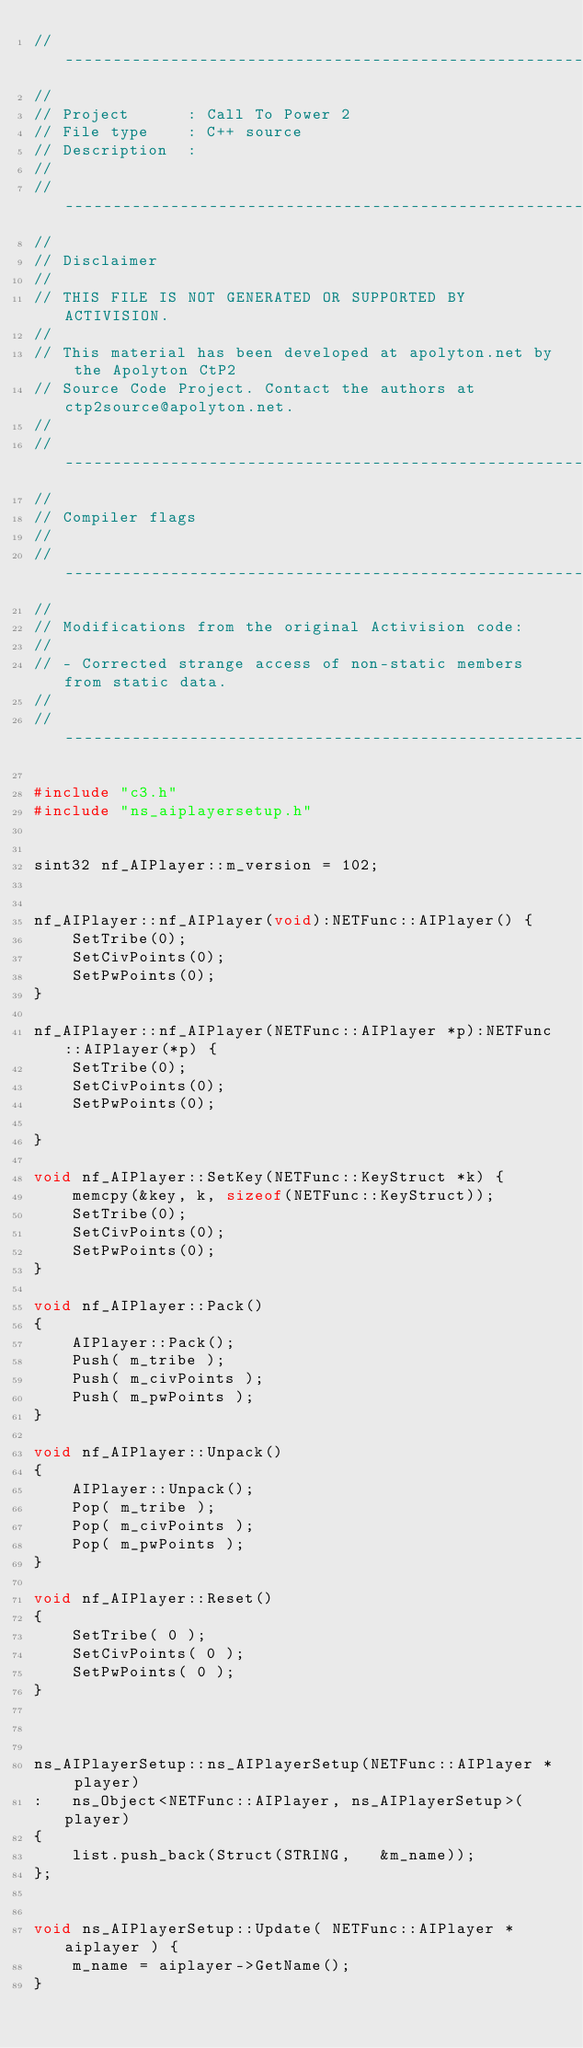Convert code to text. <code><loc_0><loc_0><loc_500><loc_500><_C++_>//----------------------------------------------------------------------------
//
// Project      : Call To Power 2
// File type    : C++ source
// Description  : 
//
//----------------------------------------------------------------------------
//
// Disclaimer
//
// THIS FILE IS NOT GENERATED OR SUPPORTED BY ACTIVISION.
//
// This material has been developed at apolyton.net by the Apolyton CtP2 
// Source Code Project. Contact the authors at ctp2source@apolyton.net.
//
//----------------------------------------------------------------------------
//
// Compiler flags
// 
//----------------------------------------------------------------------------
//
// Modifications from the original Activision code:
//
// - Corrected strange access of non-static members from static data.
//
//----------------------------------------------------------------------------

#include "c3.h"
#include "ns_aiplayersetup.h"


sint32 nf_AIPlayer::m_version = 102;


nf_AIPlayer::nf_AIPlayer(void):NETFunc::AIPlayer() {
	SetTribe(0);
	SetCivPoints(0);
	SetPwPoints(0);
}

nf_AIPlayer::nf_AIPlayer(NETFunc::AIPlayer *p):NETFunc::AIPlayer(*p) {
	SetTribe(0);
	SetCivPoints(0);
	SetPwPoints(0);

}

void nf_AIPlayer::SetKey(NETFunc::KeyStruct *k) {
	memcpy(&key, k, sizeof(NETFunc::KeyStruct));
	SetTribe(0);
	SetCivPoints(0);
	SetPwPoints(0);
}

void nf_AIPlayer::Pack()
{
	AIPlayer::Pack();
	Push( m_tribe );
	Push( m_civPoints );
	Push( m_pwPoints );
}

void nf_AIPlayer::Unpack()
{
	AIPlayer::Unpack();
	Pop( m_tribe );
	Pop( m_civPoints );
	Pop( m_pwPoints );
}

void nf_AIPlayer::Reset()
{
	SetTribe( 0 );
	SetCivPoints( 0 );
	SetPwPoints( 0 );
}



ns_AIPlayerSetup::ns_AIPlayerSetup(NETFunc::AIPlayer * player) 
:	ns_Object<NETFunc::AIPlayer, ns_AIPlayerSetup>(player) 
{
	list.push_back(Struct(STRING,	&m_name));
};


void ns_AIPlayerSetup::Update( NETFunc::AIPlayer *aiplayer ) {
	m_name = aiplayer->GetName();
}
</code> 